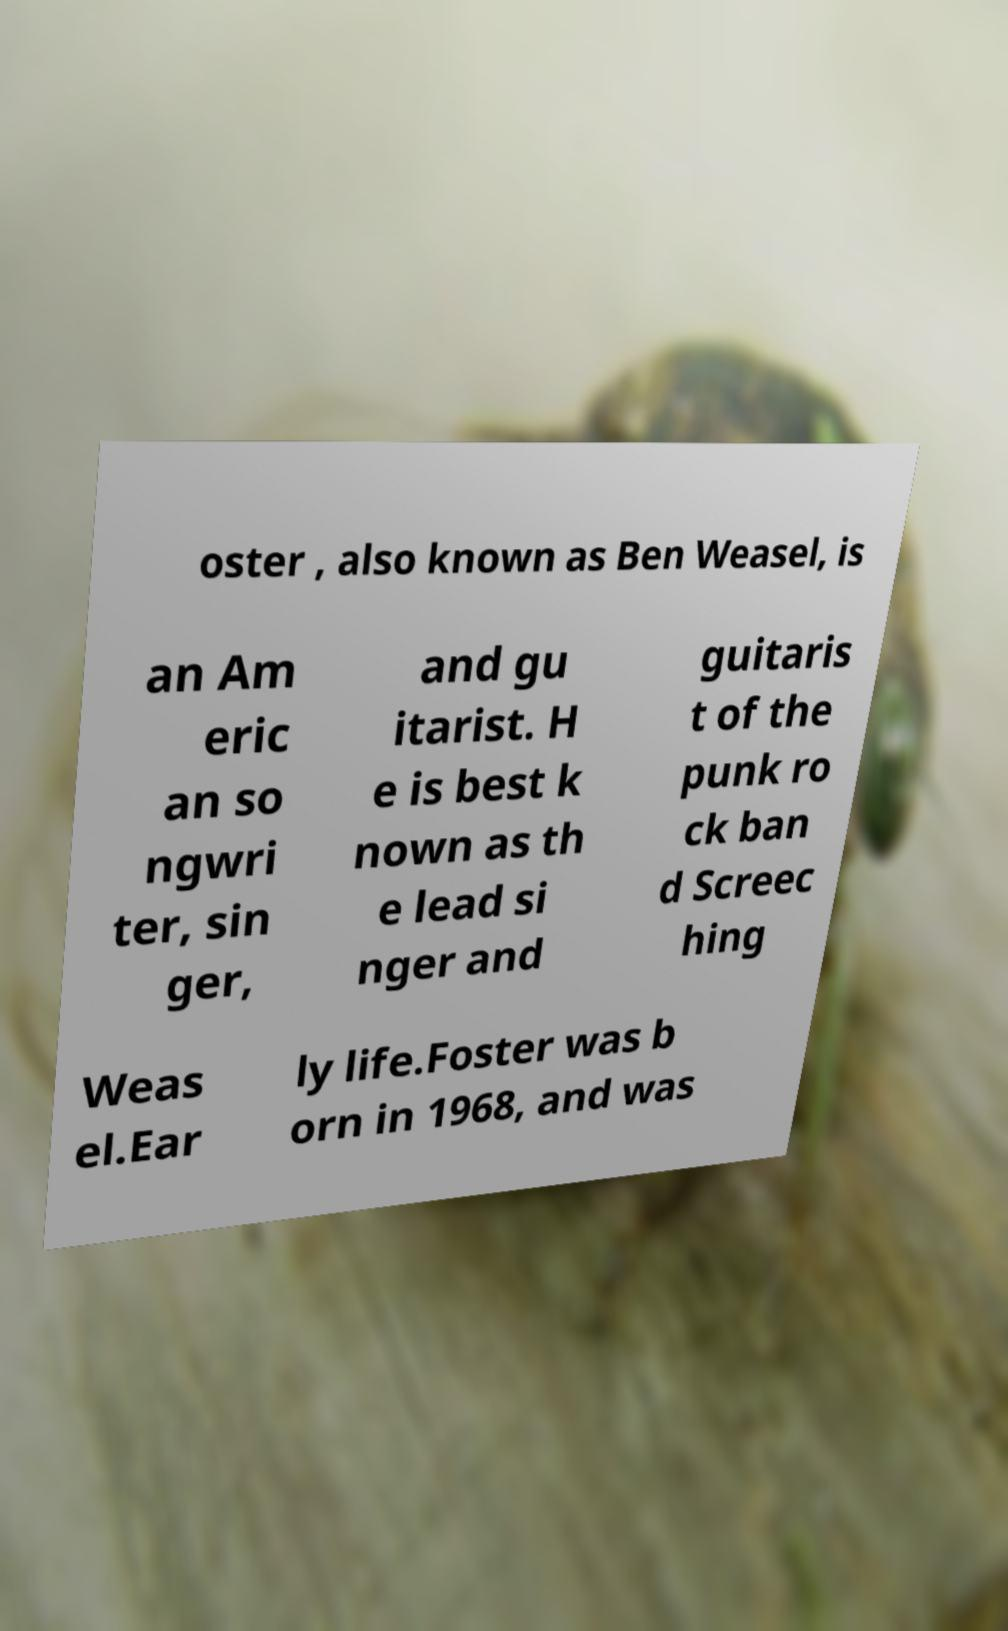I need the written content from this picture converted into text. Can you do that? oster , also known as Ben Weasel, is an Am eric an so ngwri ter, sin ger, and gu itarist. H e is best k nown as th e lead si nger and guitaris t of the punk ro ck ban d Screec hing Weas el.Ear ly life.Foster was b orn in 1968, and was 